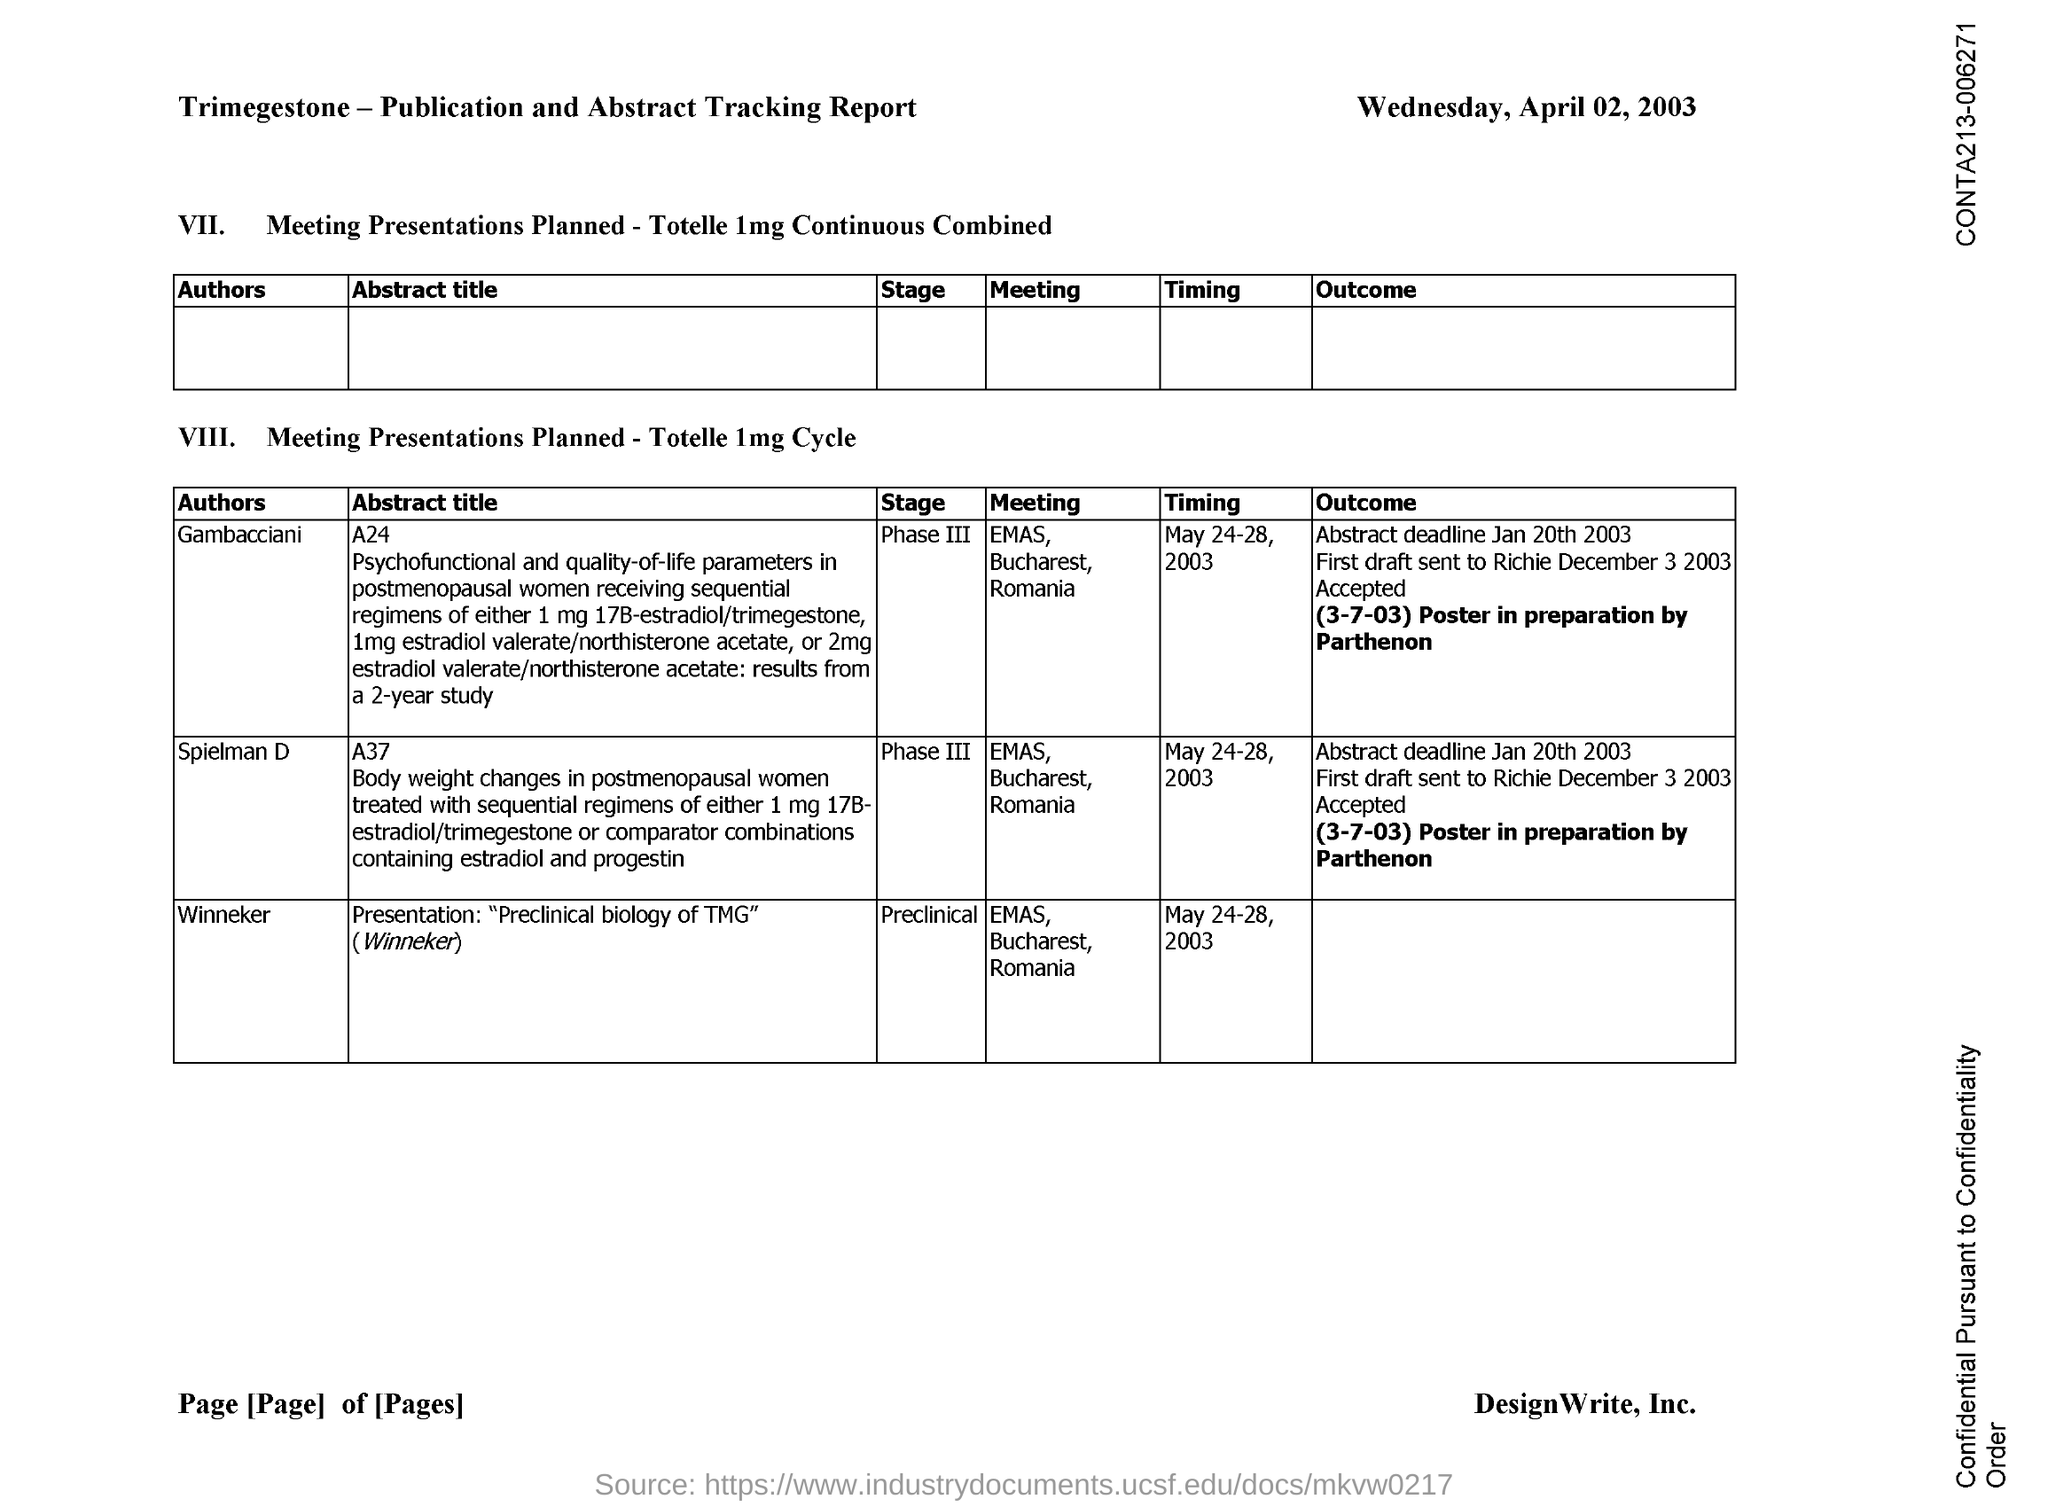Give some essential details in this illustration. The stage for author Winneker is preclinical. 